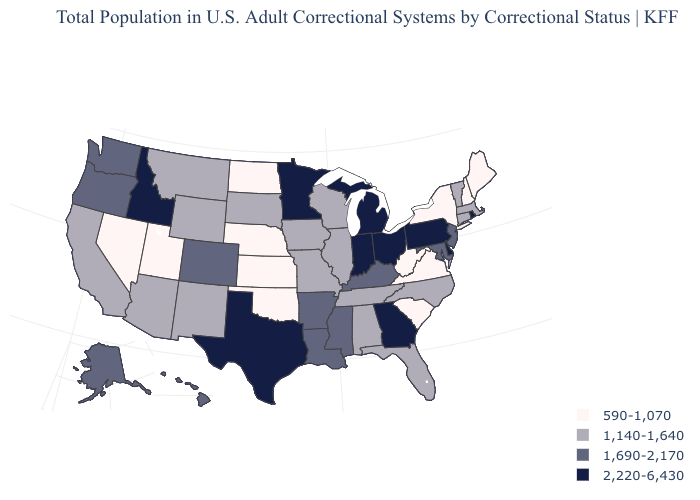Among the states that border North Dakota , does Montana have the highest value?
Concise answer only. No. Does the first symbol in the legend represent the smallest category?
Answer briefly. Yes. Which states have the lowest value in the USA?
Short answer required. Kansas, Maine, Nebraska, Nevada, New Hampshire, New York, North Dakota, Oklahoma, South Carolina, Utah, Virginia, West Virginia. Among the states that border Alabama , does Mississippi have the lowest value?
Write a very short answer. No. Does New Hampshire have the lowest value in the USA?
Concise answer only. Yes. What is the lowest value in the MidWest?
Be succinct. 590-1,070. Does Rhode Island have the highest value in the Northeast?
Keep it brief. Yes. Which states have the lowest value in the USA?
Be succinct. Kansas, Maine, Nebraska, Nevada, New Hampshire, New York, North Dakota, Oklahoma, South Carolina, Utah, Virginia, West Virginia. What is the value of Missouri?
Answer briefly. 1,140-1,640. Among the states that border Arkansas , which have the lowest value?
Write a very short answer. Oklahoma. Among the states that border Minnesota , which have the highest value?
Concise answer only. Iowa, South Dakota, Wisconsin. Is the legend a continuous bar?
Keep it brief. No. Does Iowa have a lower value than Kansas?
Be succinct. No. Which states have the lowest value in the MidWest?
Be succinct. Kansas, Nebraska, North Dakota. Does Minnesota have the same value as Indiana?
Short answer required. Yes. 